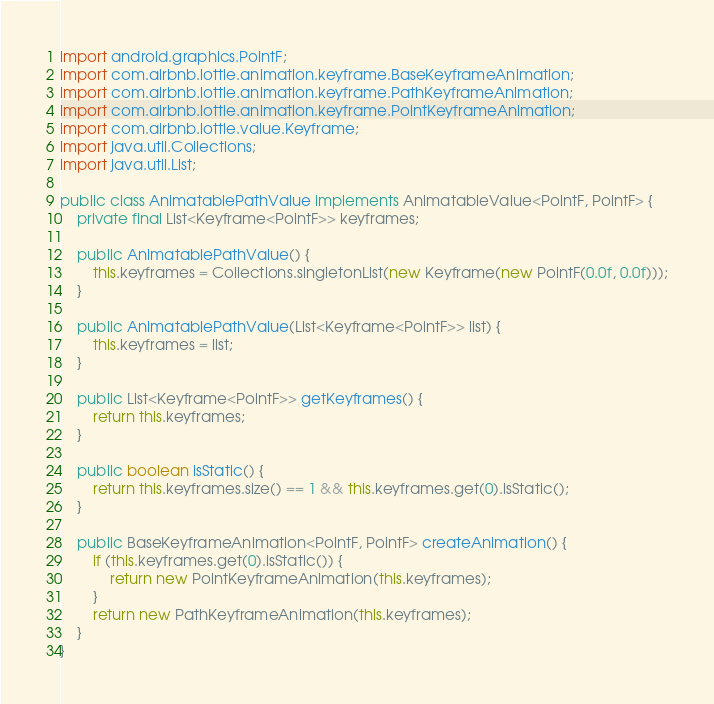Convert code to text. <code><loc_0><loc_0><loc_500><loc_500><_Java_>import android.graphics.PointF;
import com.airbnb.lottie.animation.keyframe.BaseKeyframeAnimation;
import com.airbnb.lottie.animation.keyframe.PathKeyframeAnimation;
import com.airbnb.lottie.animation.keyframe.PointKeyframeAnimation;
import com.airbnb.lottie.value.Keyframe;
import java.util.Collections;
import java.util.List;

public class AnimatablePathValue implements AnimatableValue<PointF, PointF> {
    private final List<Keyframe<PointF>> keyframes;

    public AnimatablePathValue() {
        this.keyframes = Collections.singletonList(new Keyframe(new PointF(0.0f, 0.0f)));
    }

    public AnimatablePathValue(List<Keyframe<PointF>> list) {
        this.keyframes = list;
    }

    public List<Keyframe<PointF>> getKeyframes() {
        return this.keyframes;
    }

    public boolean isStatic() {
        return this.keyframes.size() == 1 && this.keyframes.get(0).isStatic();
    }

    public BaseKeyframeAnimation<PointF, PointF> createAnimation() {
        if (this.keyframes.get(0).isStatic()) {
            return new PointKeyframeAnimation(this.keyframes);
        }
        return new PathKeyframeAnimation(this.keyframes);
    }
}
</code> 